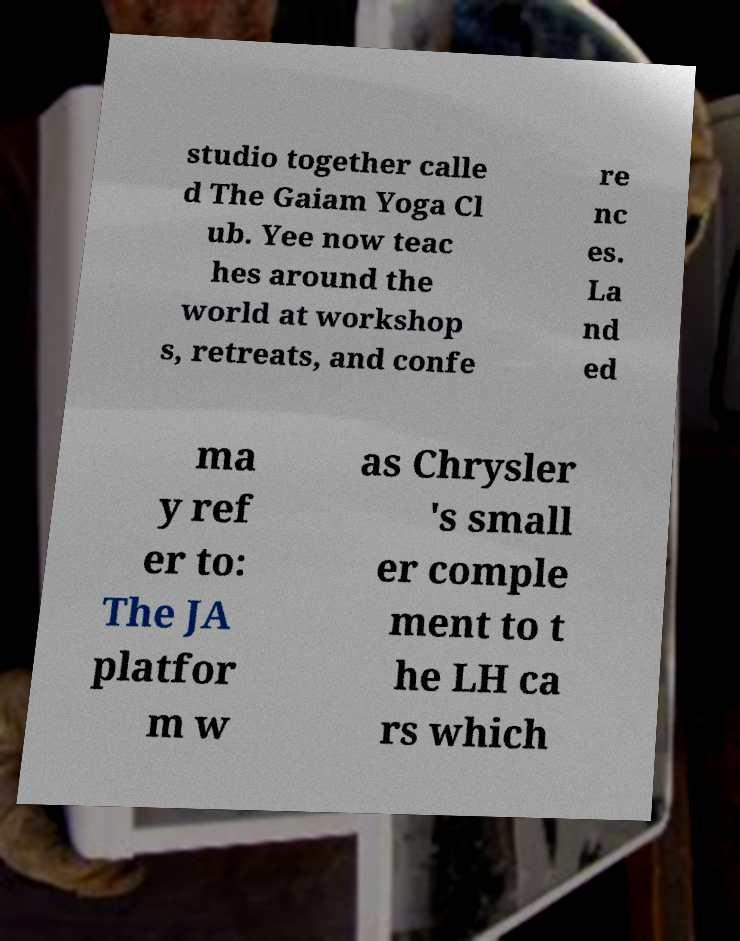Can you accurately transcribe the text from the provided image for me? studio together calle d The Gaiam Yoga Cl ub. Yee now teac hes around the world at workshop s, retreats, and confe re nc es. La nd ed ma y ref er to: The JA platfor m w as Chrysler 's small er comple ment to t he LH ca rs which 